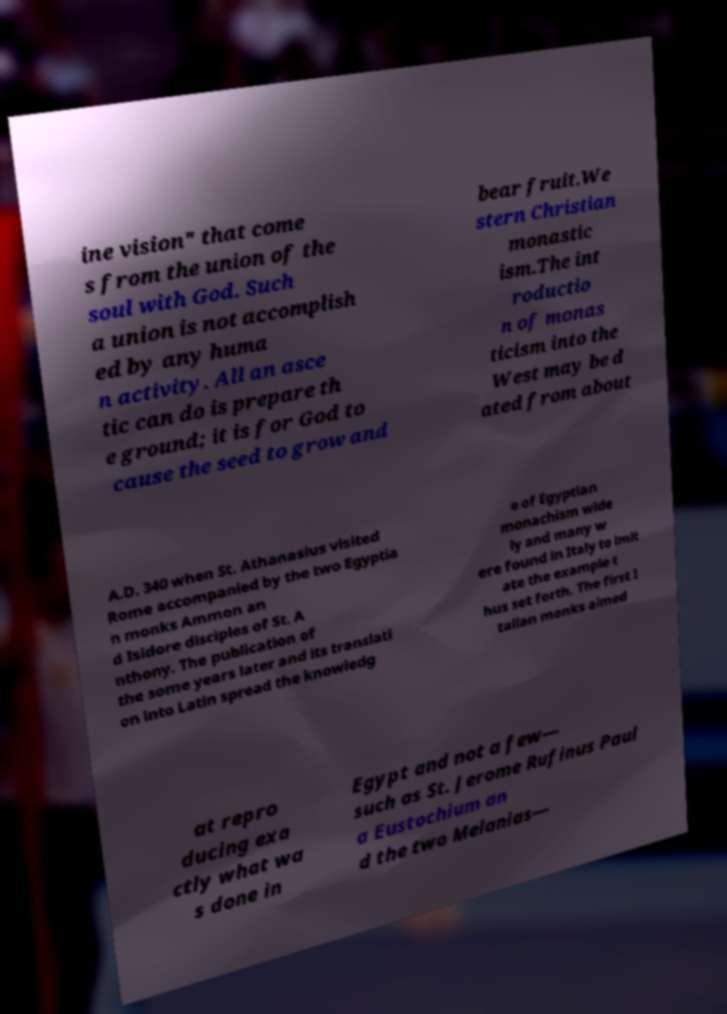Can you accurately transcribe the text from the provided image for me? ine vision" that come s from the union of the soul with God. Such a union is not accomplish ed by any huma n activity. All an asce tic can do is prepare th e ground; it is for God to cause the seed to grow and bear fruit.We stern Christian monastic ism.The int roductio n of monas ticism into the West may be d ated from about A.D. 340 when St. Athanasius visited Rome accompanied by the two Egyptia n monks Ammon an d Isidore disciples of St. A nthony. The publication of the some years later and its translati on into Latin spread the knowledg e of Egyptian monachism wide ly and many w ere found in Italy to imit ate the example t hus set forth. The first I talian monks aimed at repro ducing exa ctly what wa s done in Egypt and not a few— such as St. Jerome Rufinus Paul a Eustochium an d the two Melanias— 